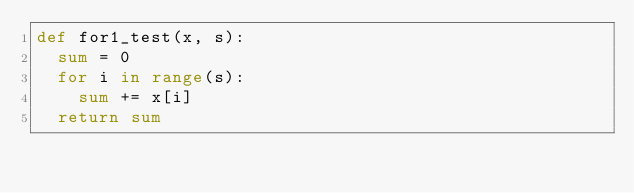<code> <loc_0><loc_0><loc_500><loc_500><_Python_>def for1_test(x, s):
  sum = 0
  for i in range(s):
    sum += x[i]
  return sum
</code> 